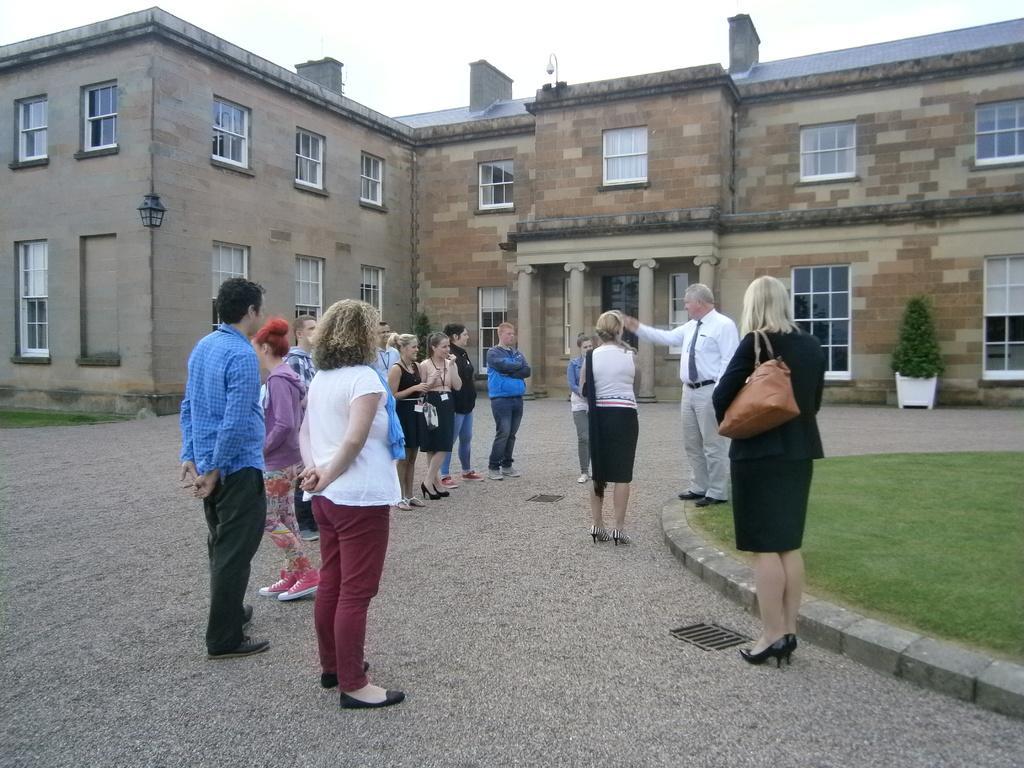Describe this image in one or two sentences. In this picture we can see a few people on the path. Some grass is visible on the ground on the right side. There is a flower pot on the path at the back. We can see a building in the background. There is a lantern, windows and other objects are visible on this building. 